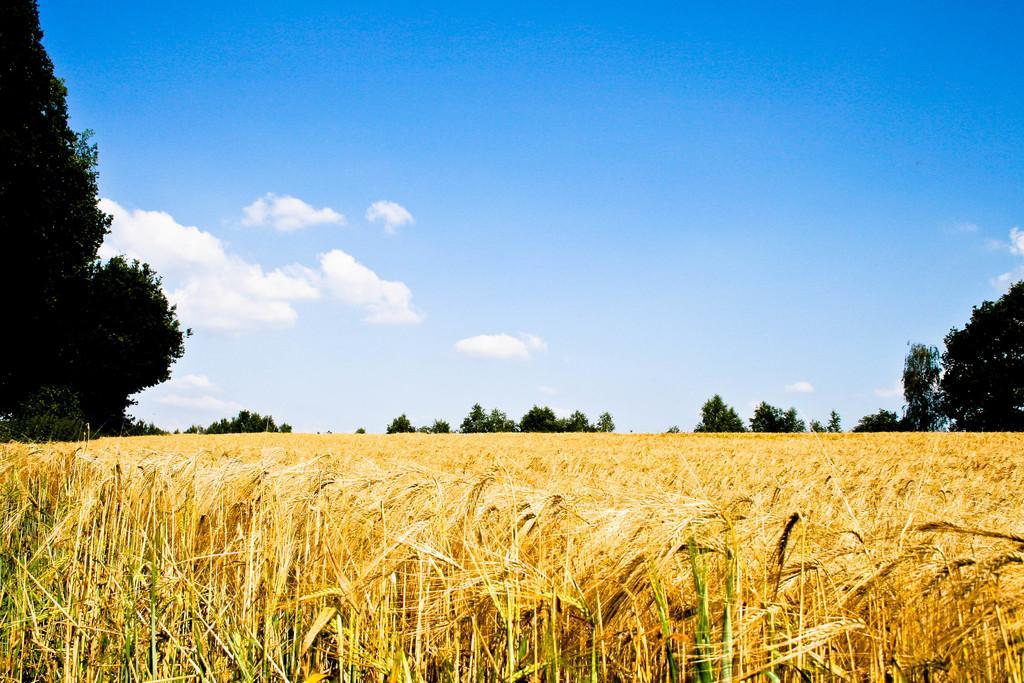Please provide a concise description of this image. There is a field. In the background there are trees and sky with clouds. 